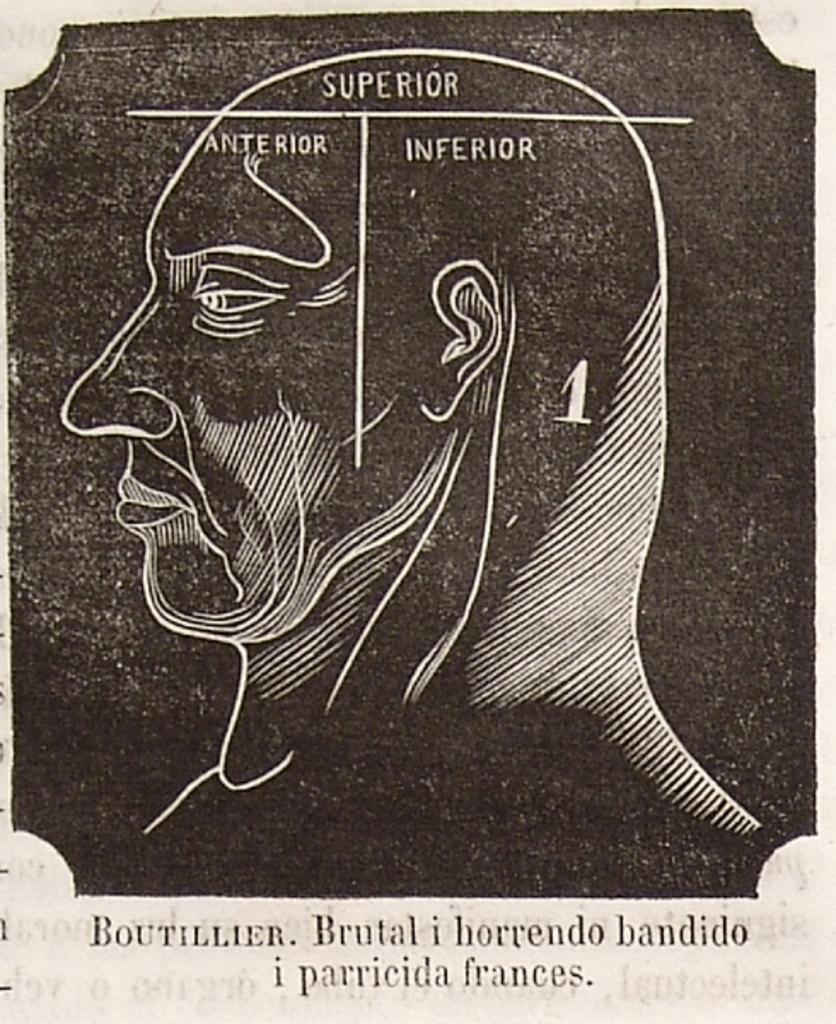Please provide a concise description of this image. In the image we can see on the poster there is an outline of a human face and the matter is written on the poster. The image is in black and white colour. 